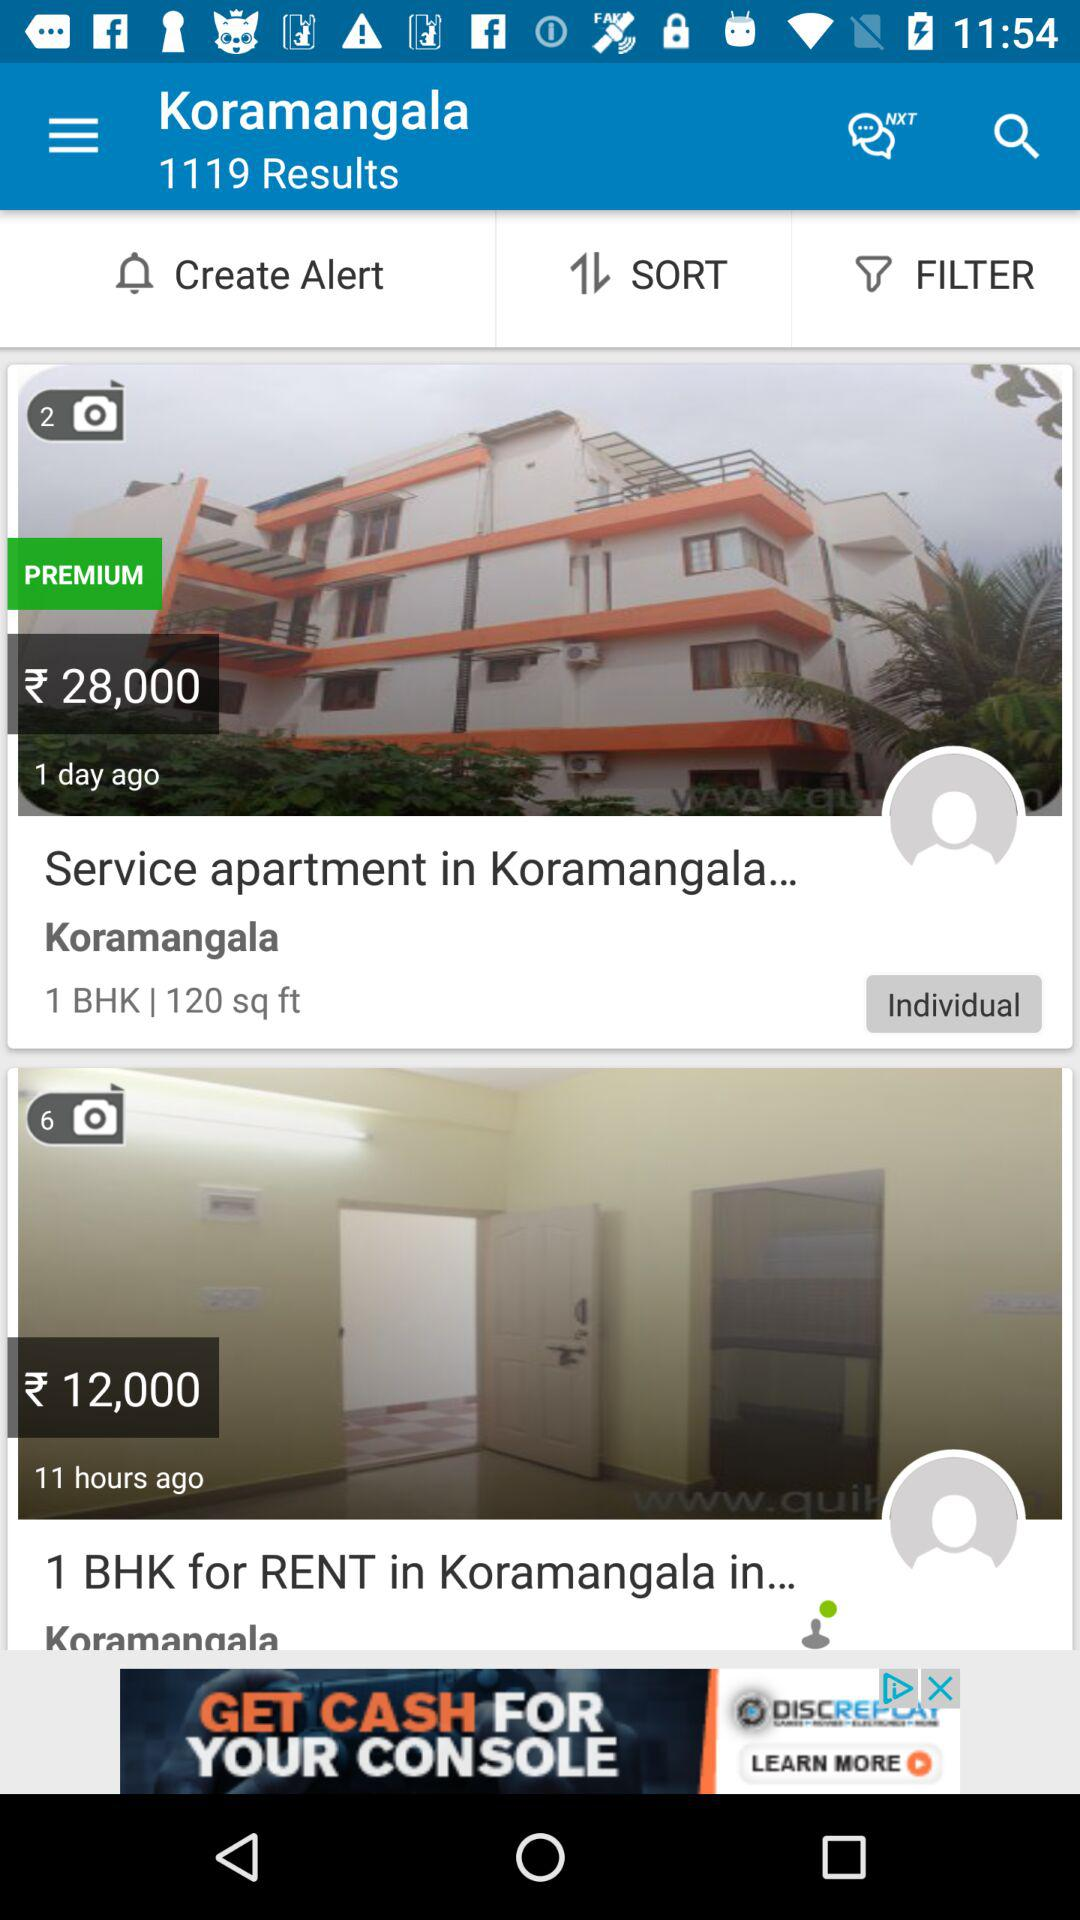How many photos in total are there of a 1 BHK service apartment in Koramangala? There are 2 photos in total. 